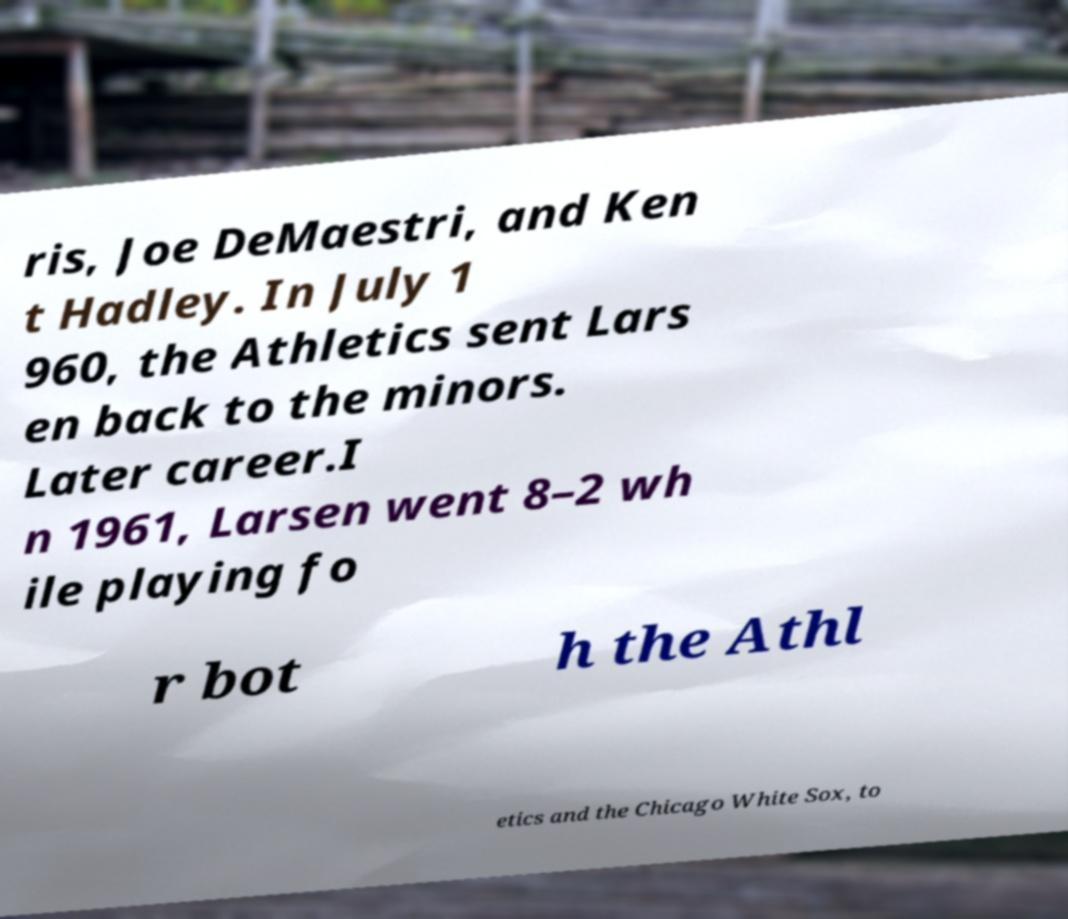Could you extract and type out the text from this image? ris, Joe DeMaestri, and Ken t Hadley. In July 1 960, the Athletics sent Lars en back to the minors. Later career.I n 1961, Larsen went 8–2 wh ile playing fo r bot h the Athl etics and the Chicago White Sox, to 